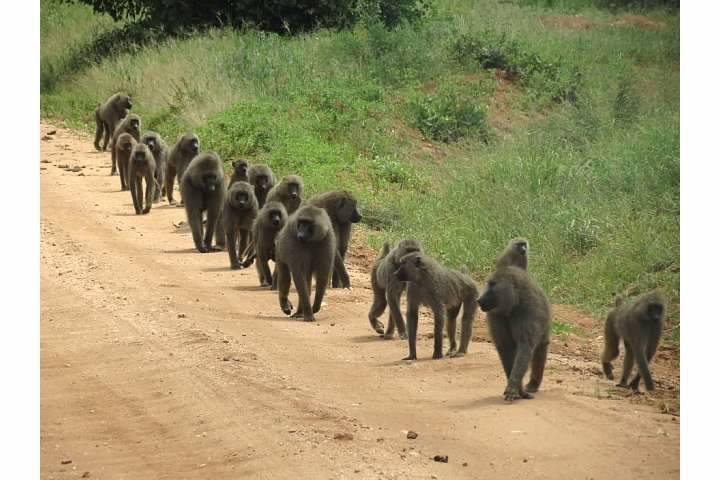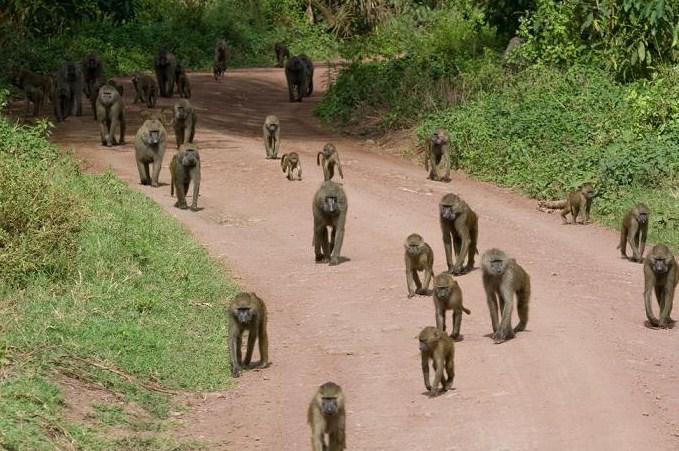The first image is the image on the left, the second image is the image on the right. For the images displayed, is the sentence "There is a large group of baboons walking on a dirt road." factually correct? Answer yes or no. Yes. 